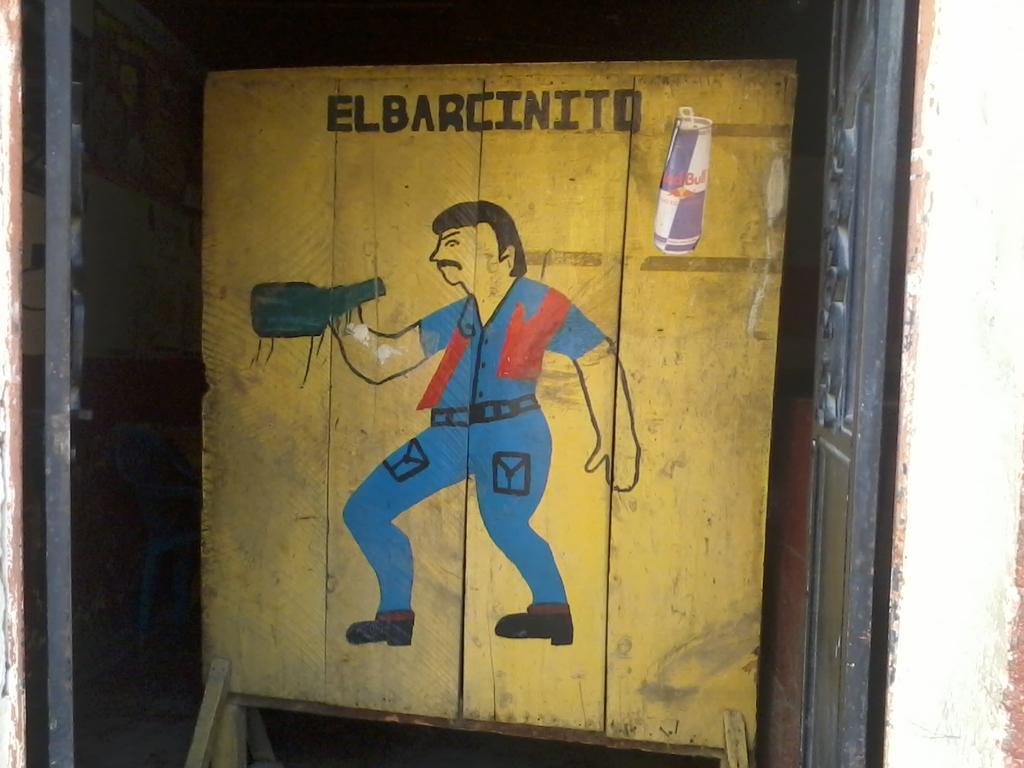Describe this image in one or two sentences. In this image I can see the yellow color wooden board. On the board I can see the I can see the painting of the person and holding something. The person is wearing the blue and red color. To the left I can see the rods and wall. 